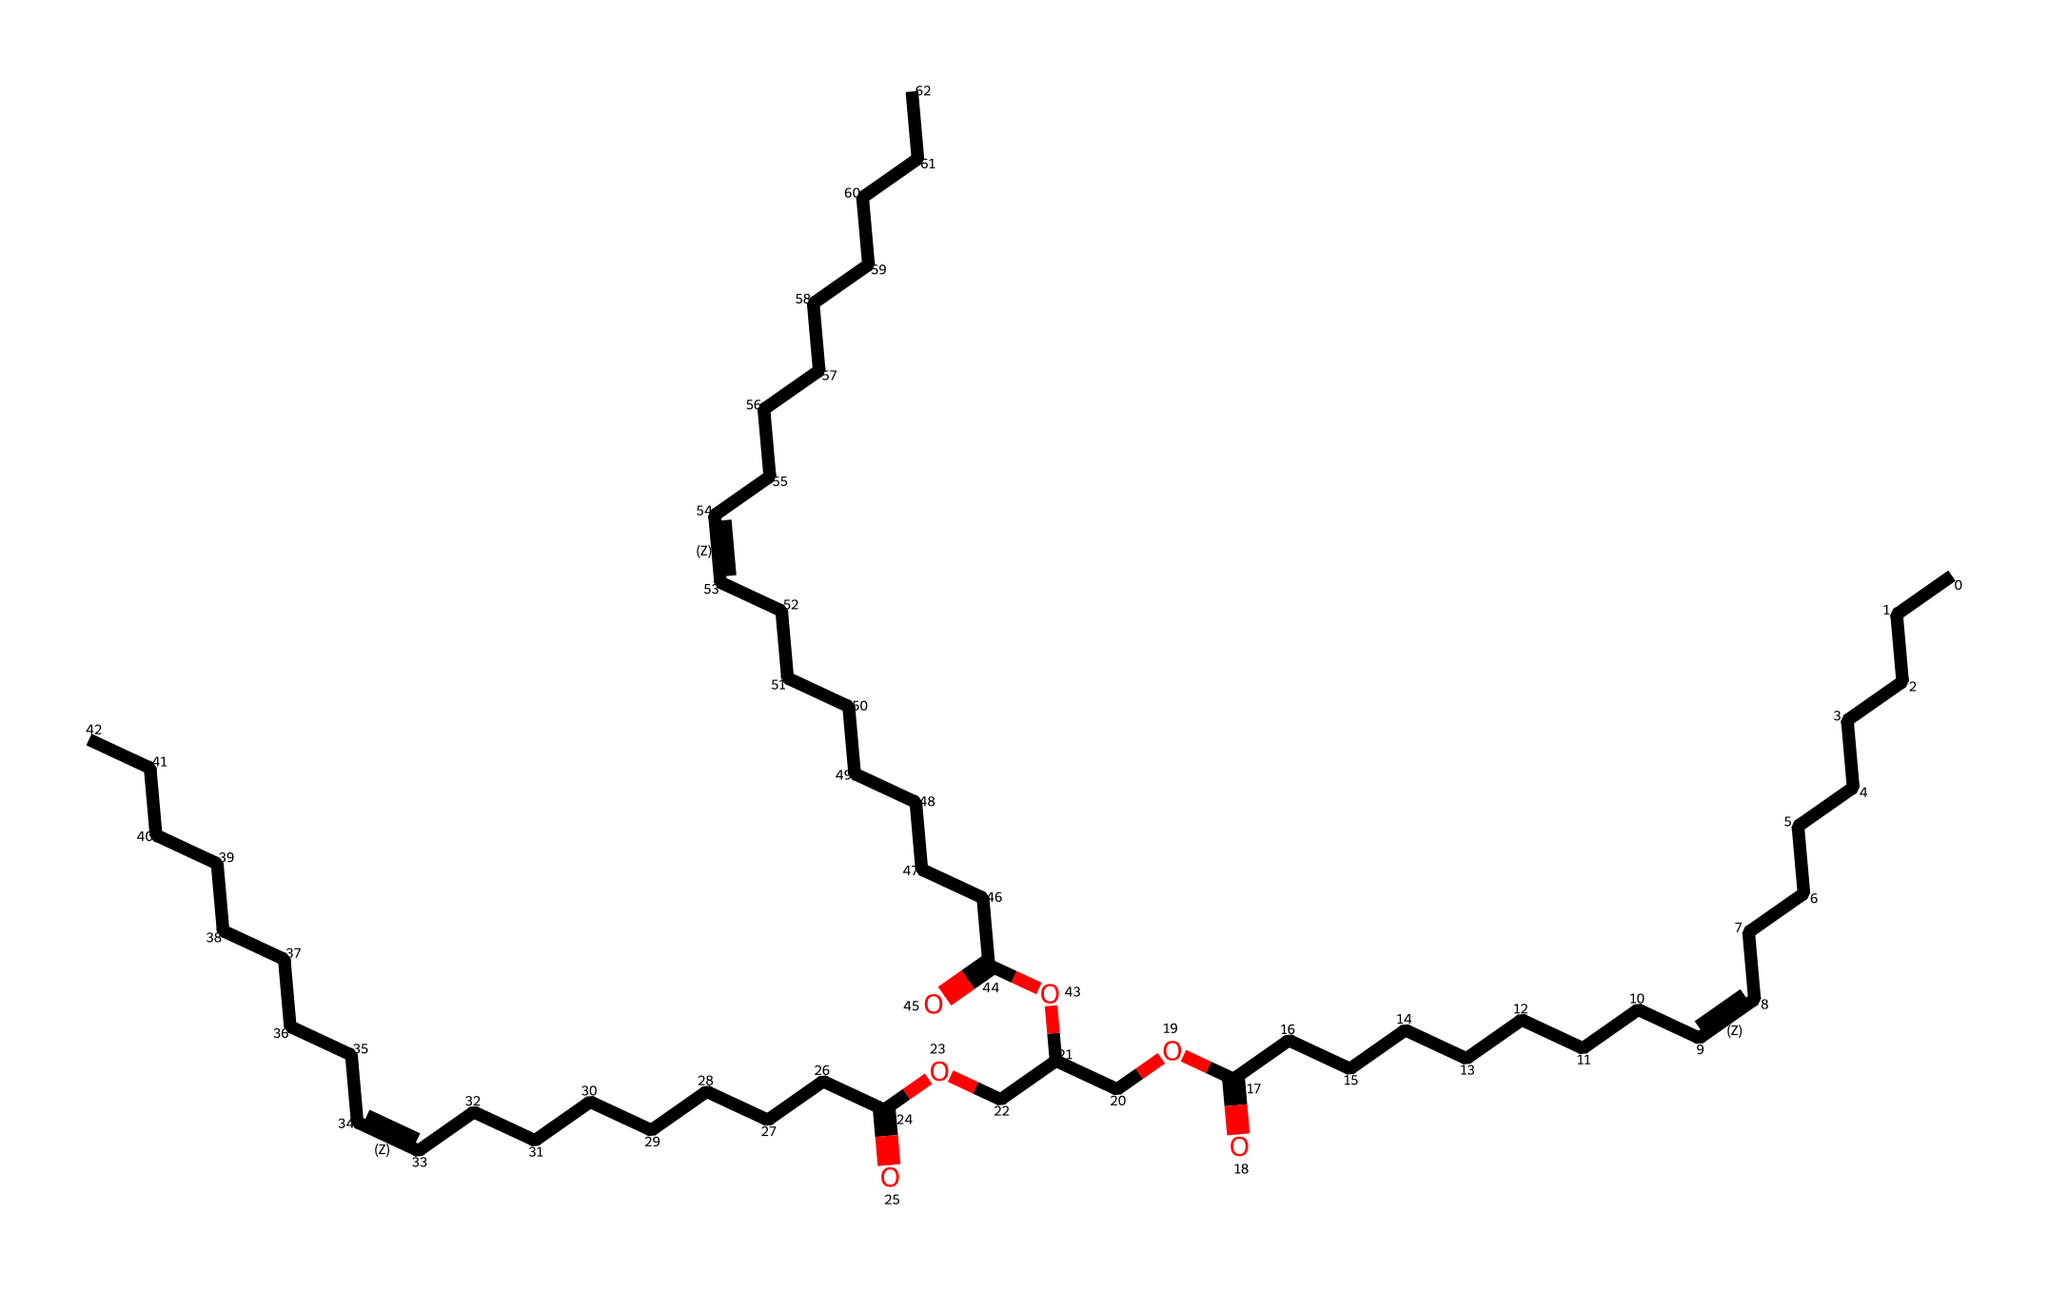What is the primary functional group present in this chemical structure? The presence of the -COOH group indicates that this chemical contains a carboxylic acid functional group, which is a key feature of olive oil.
Answer: carboxylic acid How many carbon atoms are present in this structure? By counting the number of 'C' in the SMILES representation, each section corresponds to a carbon atom, leading to a total count of 36 carbon atoms.
Answer: 36 What type of molecule is represented by this chemical structure? The structure displays characteristics of a triglyceride, identified by the glycerol backbone and three fatty acid chains, common in oils like olive oil.
Answer: triglyceride What kind of bonds are primarily present in this chemical structure? The structure contains single (sigma) and double bonds; therefore, the presence of unsaturation indicates the inclusion of at least one double bond in the fatty acid chains.
Answer: double bonds What does the presence of multiple -O- atoms indicate about the properties of this chemical? The multiple -O- atoms suggest a higher solubility in polar solvents and potential emulsifying properties, essential in culinary applications.
Answer: emulsifying properties Which specific molecule is commonly referenced as a lubricant in Mediterranean cuisine? This chemical structure corresponds closely to olive oil, which is frequently used as a lubricant in cooking and dressing.
Answer: olive oil 